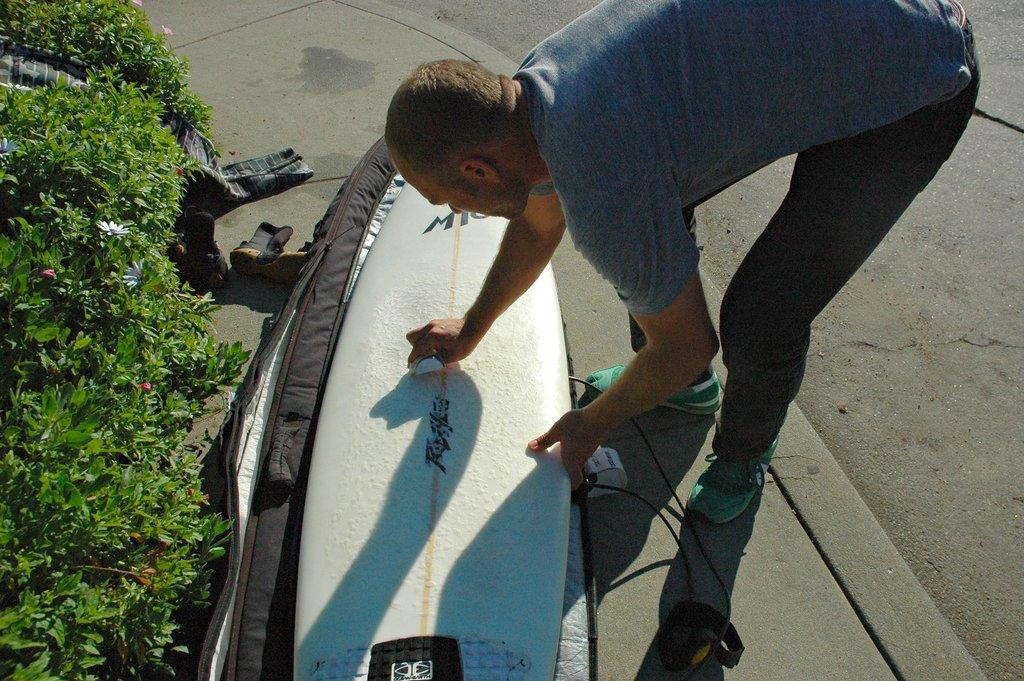Please provide a concise description of this image. These are flower plants. We can see a man bending and cleaning a surfboard which is on the floor. 